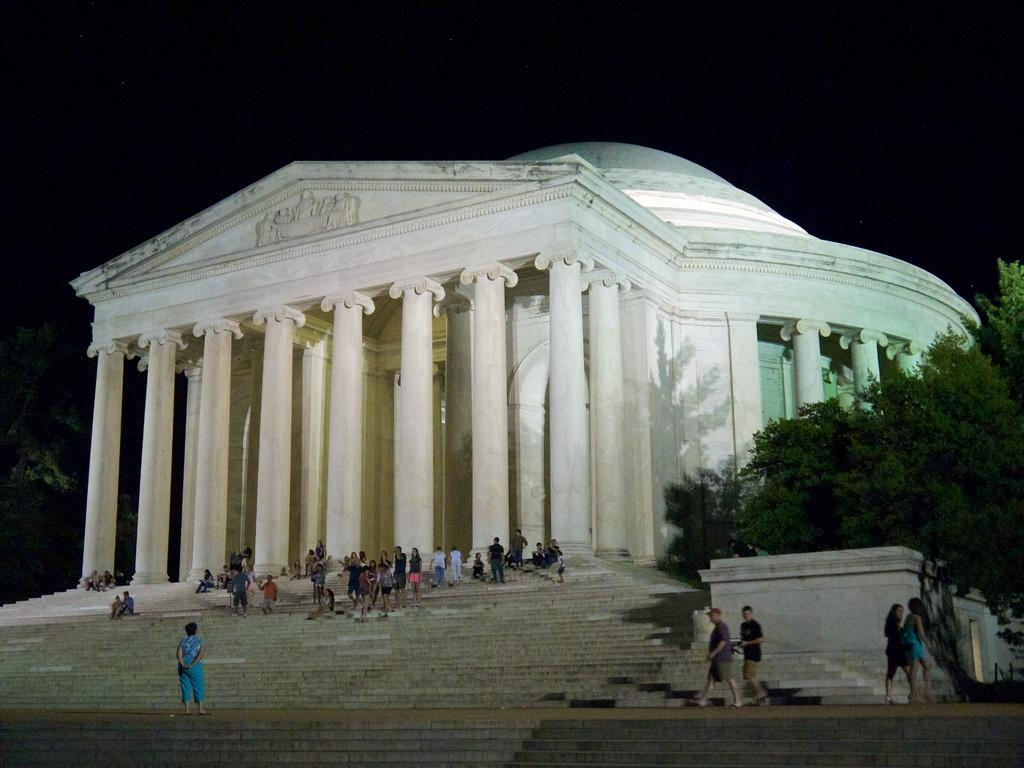What is the main structure in the center of the image? There is a building in the center of the image. What architectural feature is present in the image? There are staircases in the image. Are there any people in the image? Yes, there are people on the staircases. What type of vegetation can be seen on the right side of the image? There is a tree to the right side of the image. How many pumps are visible in the image? There are no pumps present in the image. What type of crib is located on the fifth floor of the building? There is no crib present in the image, and the image does not provide information about the floors of the building. 